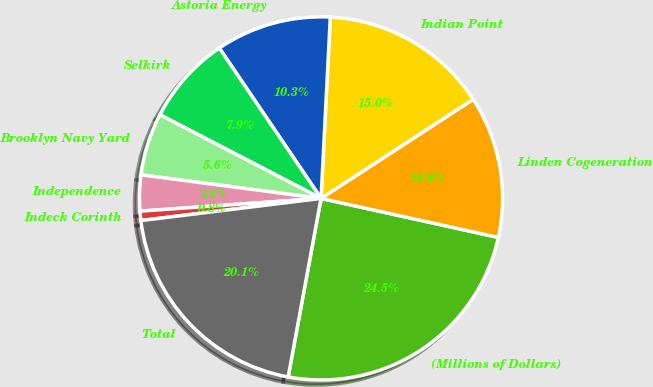Convert chart to OTSL. <chart><loc_0><loc_0><loc_500><loc_500><pie_chart><fcel>(Millions of Dollars)<fcel>Linden Cogeneration<fcel>Indian Point<fcel>Astoria Energy<fcel>Selkirk<fcel>Brooklyn Navy Yard<fcel>Independence<fcel>Indeck Corinth<fcel>Total<nl><fcel>24.45%<fcel>12.64%<fcel>15.0%<fcel>10.28%<fcel>7.91%<fcel>5.55%<fcel>3.19%<fcel>0.83%<fcel>20.15%<nl></chart> 